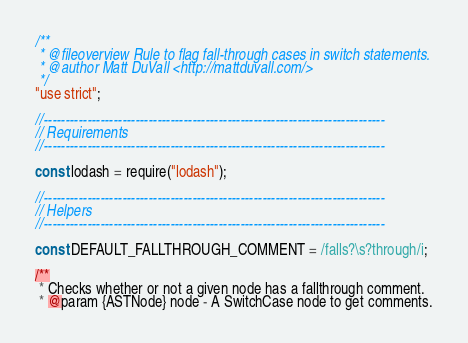Convert code to text. <code><loc_0><loc_0><loc_500><loc_500><_JavaScript_>/**
 * @fileoverview Rule to flag fall-through cases in switch statements.
 * @author Matt DuVall <http://mattduvall.com/>
 */
"use strict";

//------------------------------------------------------------------------------
// Requirements
//------------------------------------------------------------------------------

const lodash = require("lodash");

//------------------------------------------------------------------------------
// Helpers
//------------------------------------------------------------------------------

const DEFAULT_FALLTHROUGH_COMMENT = /falls?\s?through/i;

/**
 * Checks whether or not a given node has a fallthrough comment.
 * @param {ASTNode} node - A SwitchCase node to get comments.</code> 